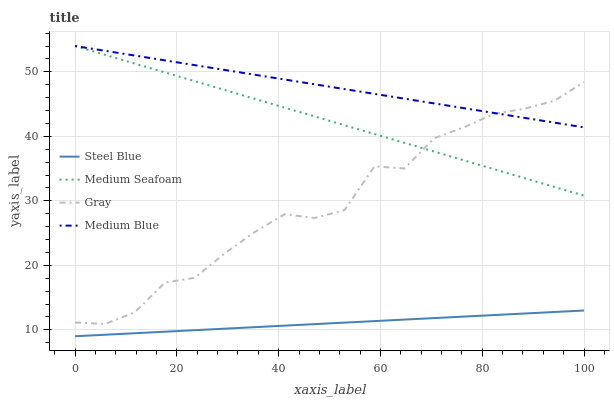Does Steel Blue have the minimum area under the curve?
Answer yes or no. Yes. Does Medium Blue have the maximum area under the curve?
Answer yes or no. Yes. Does Medium Blue have the minimum area under the curve?
Answer yes or no. No. Does Steel Blue have the maximum area under the curve?
Answer yes or no. No. Is Steel Blue the smoothest?
Answer yes or no. Yes. Is Gray the roughest?
Answer yes or no. Yes. Is Medium Blue the smoothest?
Answer yes or no. No. Is Medium Blue the roughest?
Answer yes or no. No. Does Steel Blue have the lowest value?
Answer yes or no. Yes. Does Medium Blue have the lowest value?
Answer yes or no. No. Does Medium Seafoam have the highest value?
Answer yes or no. Yes. Does Steel Blue have the highest value?
Answer yes or no. No. Is Steel Blue less than Gray?
Answer yes or no. Yes. Is Medium Blue greater than Steel Blue?
Answer yes or no. Yes. Does Medium Seafoam intersect Gray?
Answer yes or no. Yes. Is Medium Seafoam less than Gray?
Answer yes or no. No. Is Medium Seafoam greater than Gray?
Answer yes or no. No. Does Steel Blue intersect Gray?
Answer yes or no. No. 